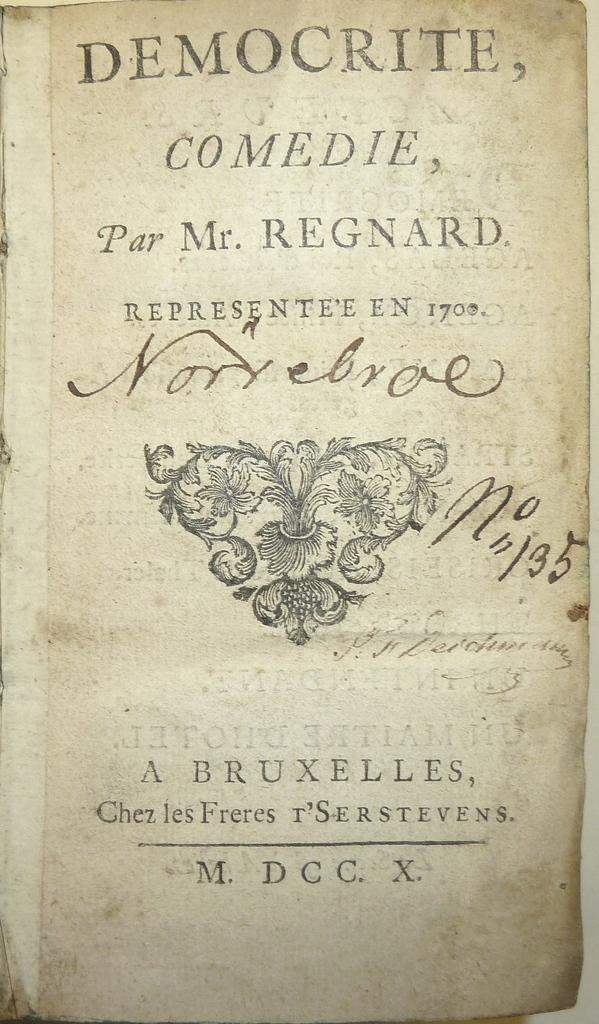<image>
Present a compact description of the photo's key features. A very old paperback book from 1700's called Democrite, Comedie by Mr. Regnard written in a foreign language. 